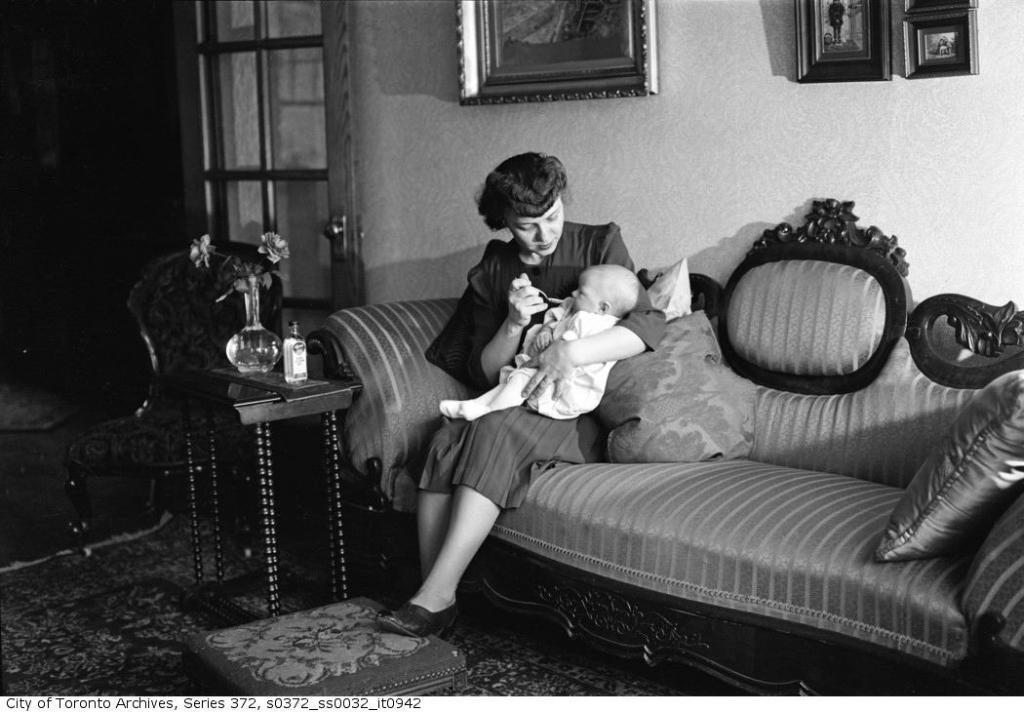Describe this image in one or two sentences. Here we can see a woman sitting on a couch feeding something to the baby in her hand, in front of her we can see a bottle and a flower vase and behind her we can see portraits present on the wall and there is a door beside that 